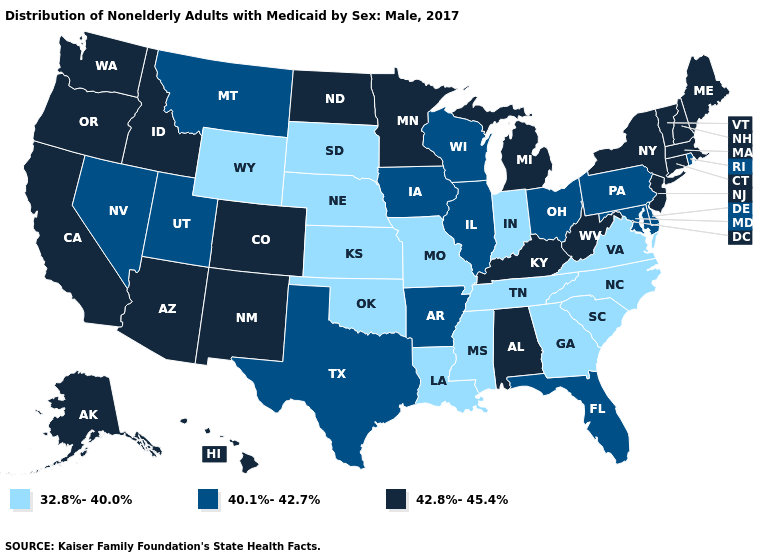What is the value of Washington?
Concise answer only. 42.8%-45.4%. What is the value of Vermont?
Concise answer only. 42.8%-45.4%. Does Idaho have the lowest value in the USA?
Concise answer only. No. Which states have the lowest value in the Northeast?
Give a very brief answer. Pennsylvania, Rhode Island. Name the states that have a value in the range 40.1%-42.7%?
Be succinct. Arkansas, Delaware, Florida, Illinois, Iowa, Maryland, Montana, Nevada, Ohio, Pennsylvania, Rhode Island, Texas, Utah, Wisconsin. What is the highest value in states that border Vermont?
Short answer required. 42.8%-45.4%. How many symbols are there in the legend?
Give a very brief answer. 3. How many symbols are there in the legend?
Short answer required. 3. What is the lowest value in states that border Tennessee?
Be succinct. 32.8%-40.0%. Name the states that have a value in the range 32.8%-40.0%?
Be succinct. Georgia, Indiana, Kansas, Louisiana, Mississippi, Missouri, Nebraska, North Carolina, Oklahoma, South Carolina, South Dakota, Tennessee, Virginia, Wyoming. What is the lowest value in the USA?
Keep it brief. 32.8%-40.0%. Name the states that have a value in the range 42.8%-45.4%?
Concise answer only. Alabama, Alaska, Arizona, California, Colorado, Connecticut, Hawaii, Idaho, Kentucky, Maine, Massachusetts, Michigan, Minnesota, New Hampshire, New Jersey, New Mexico, New York, North Dakota, Oregon, Vermont, Washington, West Virginia. Does the first symbol in the legend represent the smallest category?
Quick response, please. Yes. Does Montana have the lowest value in the USA?
Keep it brief. No. What is the value of Alabama?
Keep it brief. 42.8%-45.4%. 